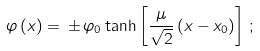Convert formula to latex. <formula><loc_0><loc_0><loc_500><loc_500>\varphi \, ( x ) = \, \pm \, { \varphi } _ { 0 } \tanh \left [ \frac { \mu } { \sqrt { 2 } } \, ( x - x _ { 0 } ) \right ] \, ;</formula> 